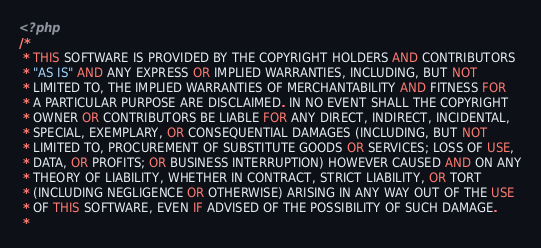Convert code to text. <code><loc_0><loc_0><loc_500><loc_500><_PHP_><?php
/*
 * THIS SOFTWARE IS PROVIDED BY THE COPYRIGHT HOLDERS AND CONTRIBUTORS
 * "AS IS" AND ANY EXPRESS OR IMPLIED WARRANTIES, INCLUDING, BUT NOT
 * LIMITED TO, THE IMPLIED WARRANTIES OF MERCHANTABILITY AND FITNESS FOR
 * A PARTICULAR PURPOSE ARE DISCLAIMED. IN NO EVENT SHALL THE COPYRIGHT
 * OWNER OR CONTRIBUTORS BE LIABLE FOR ANY DIRECT, INDIRECT, INCIDENTAL,
 * SPECIAL, EXEMPLARY, OR CONSEQUENTIAL DAMAGES (INCLUDING, BUT NOT
 * LIMITED TO, PROCUREMENT OF SUBSTITUTE GOODS OR SERVICES; LOSS OF USE,
 * DATA, OR PROFITS; OR BUSINESS INTERRUPTION) HOWEVER CAUSED AND ON ANY
 * THEORY OF LIABILITY, WHETHER IN CONTRACT, STRICT LIABILITY, OR TORT
 * (INCLUDING NEGLIGENCE OR OTHERWISE) ARISING IN ANY WAY OUT OF THE USE
 * OF THIS SOFTWARE, EVEN IF ADVISED OF THE POSSIBILITY OF SUCH DAMAGE.
 *</code> 